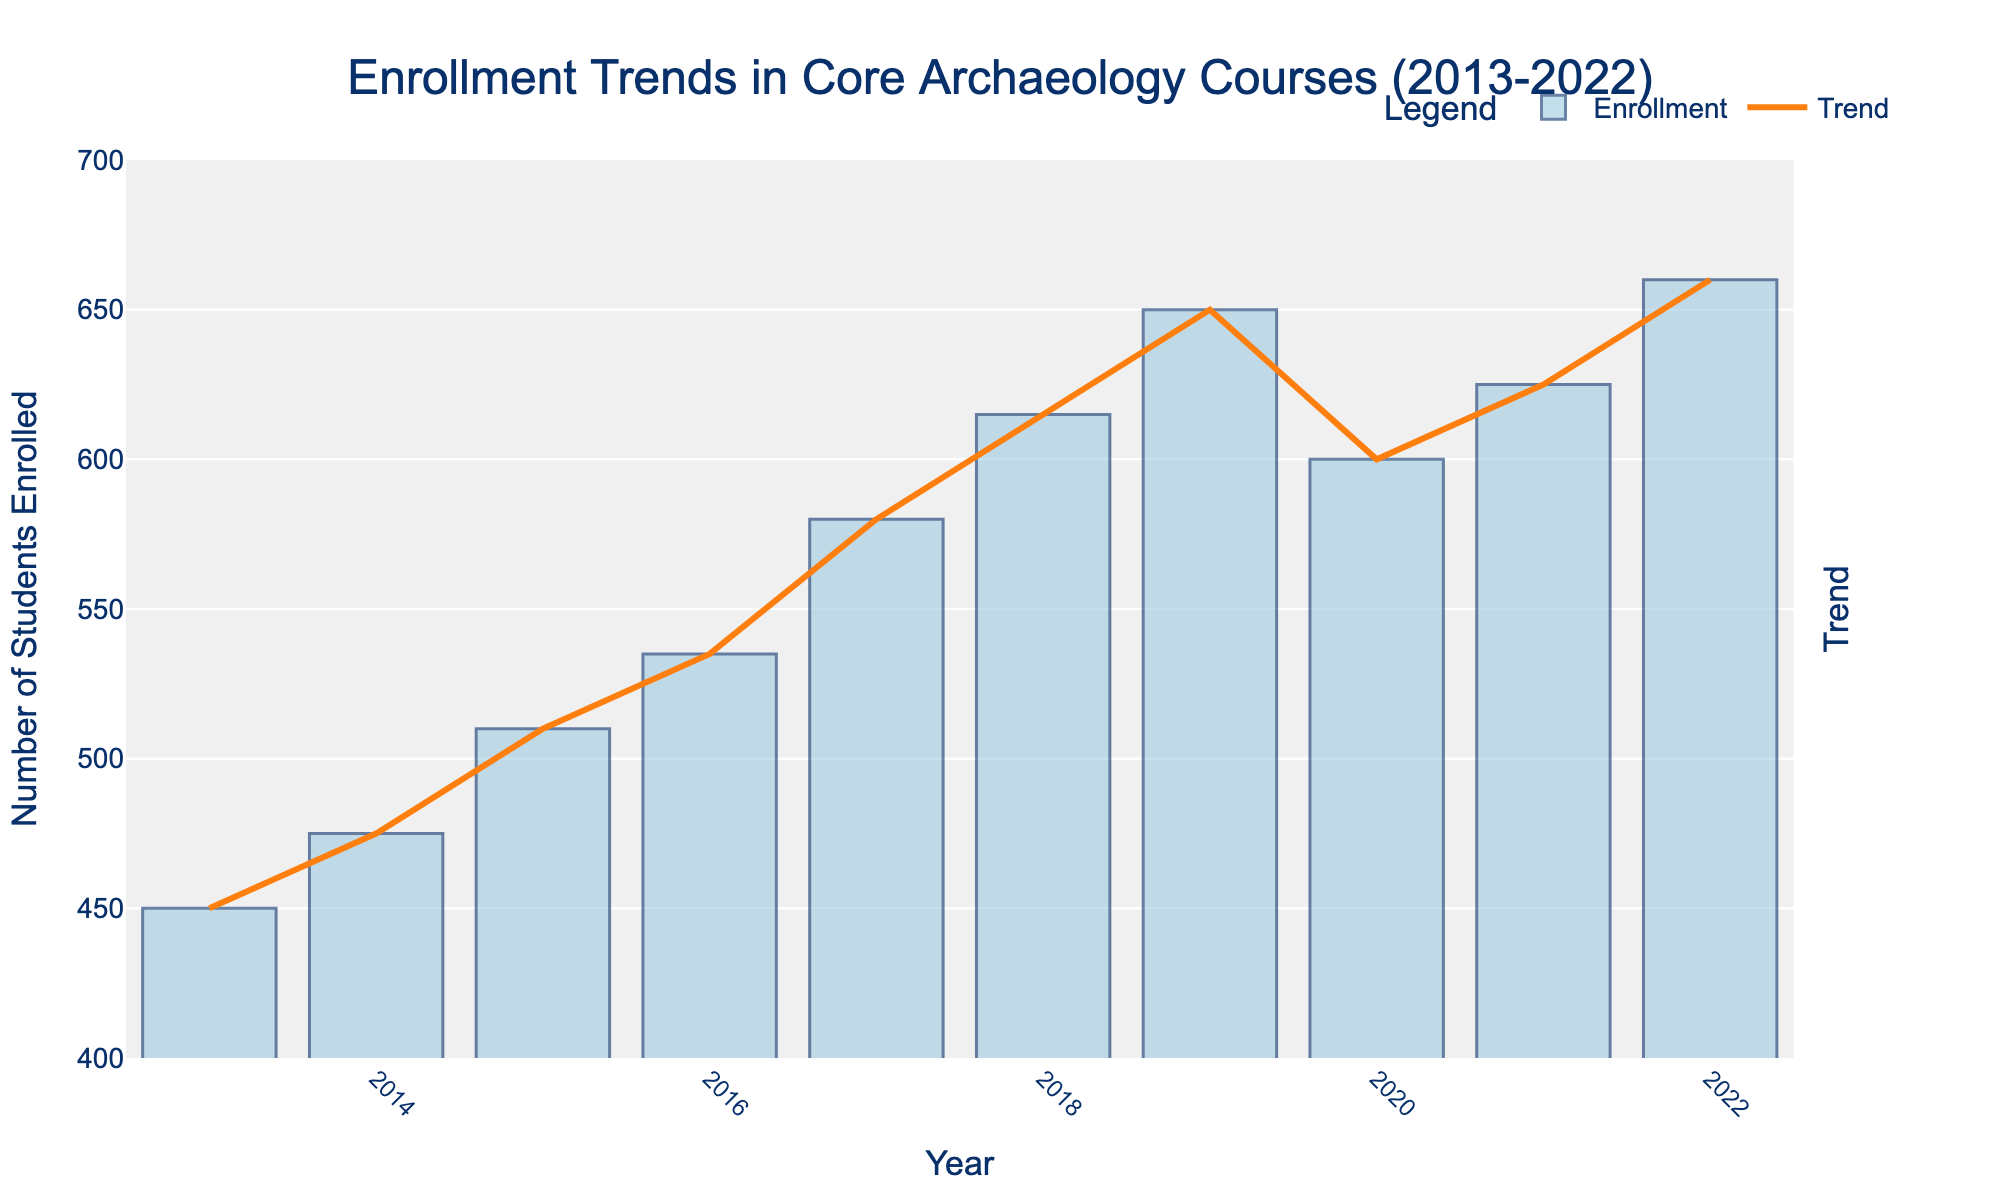What is the trend of enrollment in core archaeology courses from 2013 to 2022? To determine the trend, observe the overall direction of the bar heights and the overlayed trend line from left (2013) to right (2022) in the plot. The bars generally increase in height, reflecting an upward trend.
Answer: Upward trend Which year had the highest enrollment in core archaeology courses? Check the top of each bar to locate the highest point. The bar for 2022 is the highest, indicating the peak enrollment year.
Answer: 2022 How does the enrollment in 2016 compare to the enrollment in 2020? Find the bar heights for 2016 and 2020. The height of the 2016 bar is slightly lower than the 2020 bar. This shows that 2020 had a higher enrollment compared to 2016.
Answer: Higher in 2020 What is the average enrollment across the years 2018 to 2022? Sum the enrollments for 2018, 2019, 2020, 2021, and 2022, then divide by the number of years. (615 + 650 + 600 + 625 + 660) / 5 = 630
Answer: 630 In which year did the enrollment see the largest increase compared to the previous year? Examine the height differences between consecutive bars. The largest increase is from 2016 (535) to 2017 (580), a difference of 45.
Answer: 2017 Which two consecutive years had the smallest difference in enrollment numbers? Calculate the differences: (2022-2021)=35, (2021-2020)=25, (2020-2019)=-50, (2019-2018)=35, (2018-2017)=35, (2017-2016)=45, (2016-2015)=25, (2015-2014)=35, (2014-2013)=25. The smallest difference is between 2014 and 2013 (+25). However, this method results in three year pairs (2022-2021, 2015-2014, 2014-2013) all having the same difference.
Answer: 2013-2014 How much lower was the enrollment in 2020 compared to the previous year 2019? Subtract the enrollment of 2019 from 2020: 650 - 600 = 50
Answer: 50 What is the median enrollment from 2013 to 2018? Order the enrollment values from 2013 to 2018 (450, 475, 510, 535, 580, 615). The median is the middle value or the average of two middle values. Median = (535 + 580) / 2 = 557.5
Answer: 557.5 How did the enrollment change from 2019 to 2020? Compare the bar heights for the years 2019 and 2020. The height of the bar for 2020 is lower than the one for 2019. Thus, enrollment decreased.
Answer: Decreased What general pattern can be seen in the second half of the decade (2018-2022) compared to the first half (2013-2017)? Visually compare the bars in the two halves. The second half (2018-2022) shows higher and more stable bars compared to the first half (2013-2017), which indicates steady growth followed by minor fluctuation.
Answer: Higher and more stable 